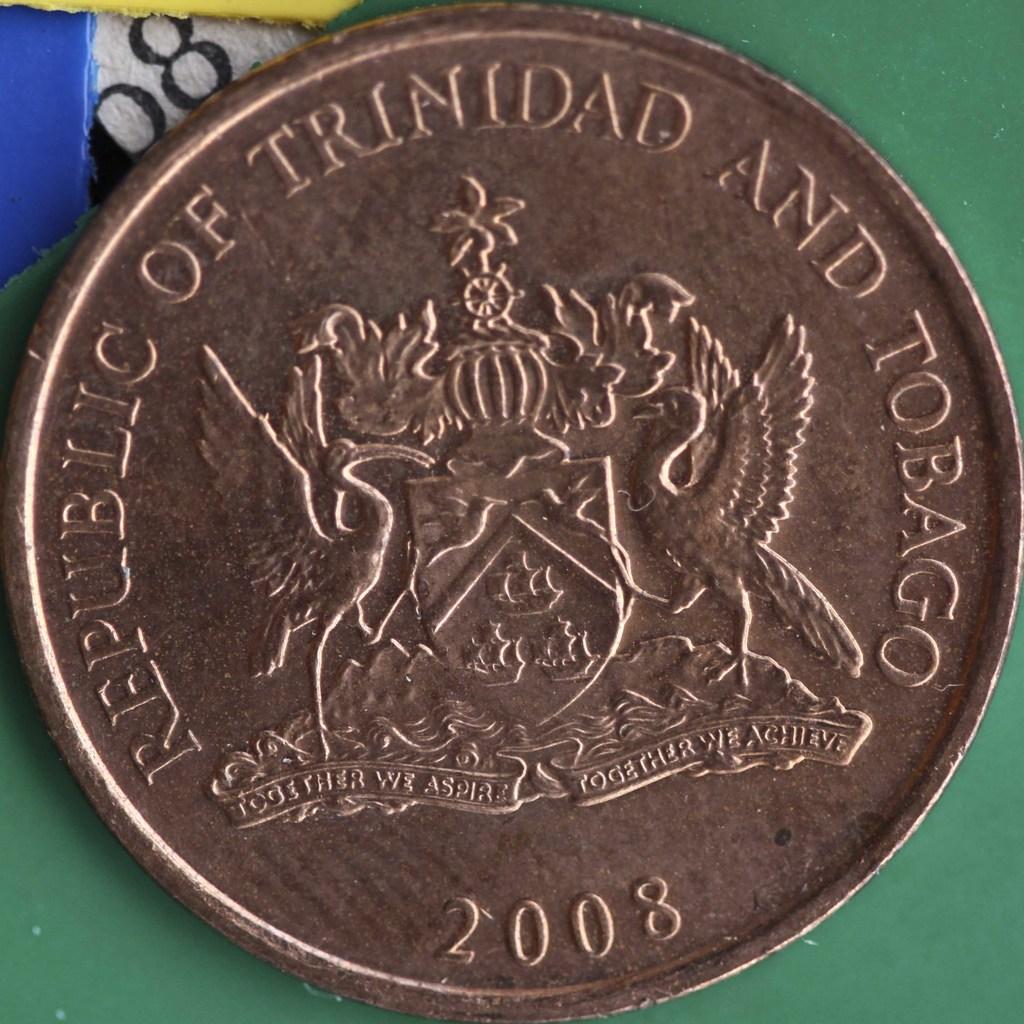What year was this coin made?
Keep it short and to the point. 2008. 